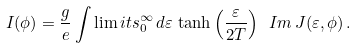<formula> <loc_0><loc_0><loc_500><loc_500>I ( \phi ) = \frac { g } { e } \int \lim i t s _ { 0 } ^ { \infty } \, d \varepsilon \, \tanh \left ( \frac { \varepsilon } { 2 T } \right ) \ I m \, J ( \varepsilon , \phi ) \, .</formula> 